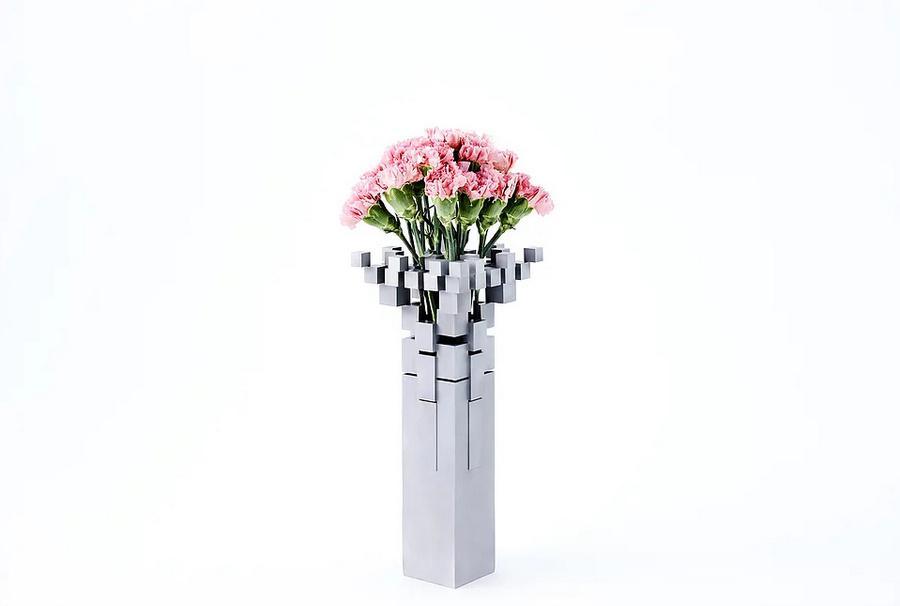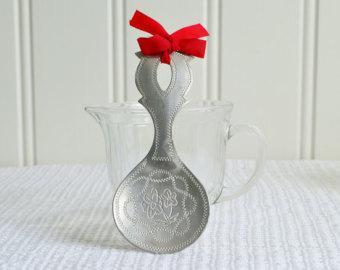The first image is the image on the left, the second image is the image on the right. Considering the images on both sides, is "There is a vase with a wide bottom that tapers to be smaller at the opening holding a single plant in it" valid? Answer yes or no. No. The first image is the image on the left, the second image is the image on the right. Given the left and right images, does the statement "In at least one image there is a single white vase that expanse at the top." hold true? Answer yes or no. Yes. 